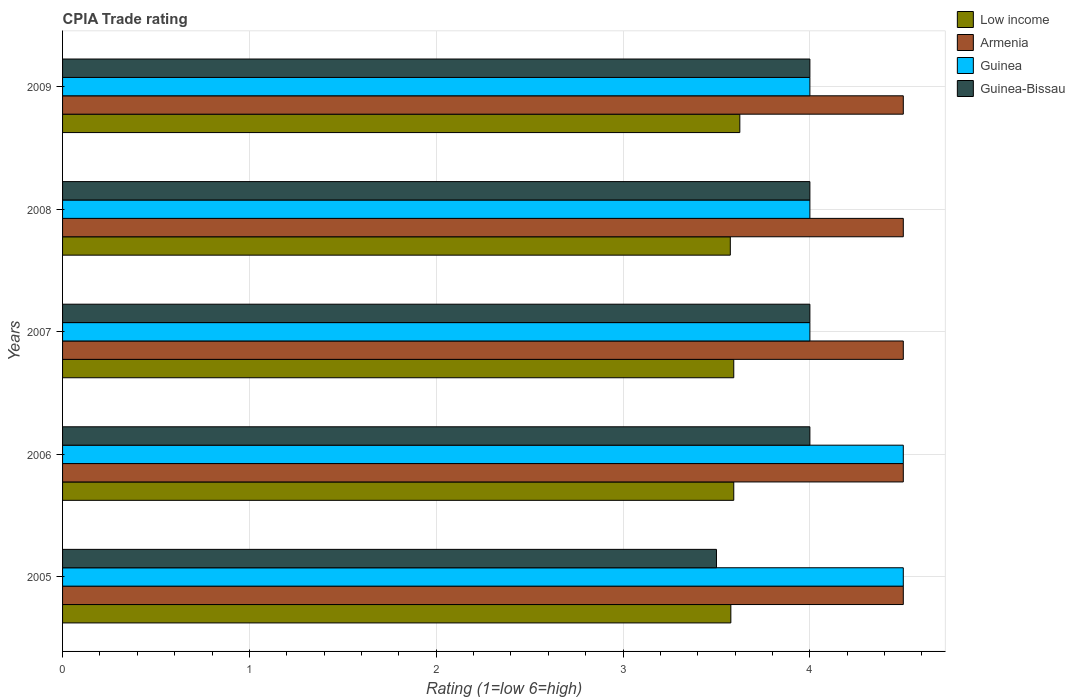How many groups of bars are there?
Your answer should be compact. 5. Are the number of bars on each tick of the Y-axis equal?
Offer a very short reply. Yes. How many bars are there on the 2nd tick from the top?
Offer a terse response. 4. What is the label of the 2nd group of bars from the top?
Ensure brevity in your answer.  2008. In how many cases, is the number of bars for a given year not equal to the number of legend labels?
Provide a short and direct response. 0. What is the CPIA rating in Guinea-Bissau in 2008?
Offer a very short reply. 4. Across all years, what is the maximum CPIA rating in Armenia?
Ensure brevity in your answer.  4.5. In which year was the CPIA rating in Low income maximum?
Your answer should be compact. 2009. What is the total CPIA rating in Low income in the graph?
Your answer should be compact. 17.96. In the year 2006, what is the difference between the CPIA rating in Guinea and CPIA rating in Guinea-Bissau?
Ensure brevity in your answer.  0.5. In how many years, is the CPIA rating in Guinea greater than 1.4 ?
Provide a succinct answer. 5. Is the difference between the CPIA rating in Guinea in 2007 and 2008 greater than the difference between the CPIA rating in Guinea-Bissau in 2007 and 2008?
Your answer should be very brief. No. What is the difference between the highest and the second highest CPIA rating in Guinea?
Offer a very short reply. 0. What is the difference between the highest and the lowest CPIA rating in Armenia?
Provide a short and direct response. 0. What does the 2nd bar from the top in 2005 represents?
Your response must be concise. Guinea. What does the 2nd bar from the bottom in 2006 represents?
Provide a short and direct response. Armenia. How many years are there in the graph?
Offer a very short reply. 5. What is the difference between two consecutive major ticks on the X-axis?
Your answer should be compact. 1. Does the graph contain grids?
Make the answer very short. Yes. Where does the legend appear in the graph?
Give a very brief answer. Top right. How many legend labels are there?
Keep it short and to the point. 4. What is the title of the graph?
Your answer should be compact. CPIA Trade rating. What is the label or title of the Y-axis?
Ensure brevity in your answer.  Years. What is the Rating (1=low 6=high) of Low income in 2005?
Provide a succinct answer. 3.58. What is the Rating (1=low 6=high) of Armenia in 2005?
Make the answer very short. 4.5. What is the Rating (1=low 6=high) in Guinea-Bissau in 2005?
Give a very brief answer. 3.5. What is the Rating (1=low 6=high) of Low income in 2006?
Keep it short and to the point. 3.59. What is the Rating (1=low 6=high) in Armenia in 2006?
Give a very brief answer. 4.5. What is the Rating (1=low 6=high) of Guinea-Bissau in 2006?
Your answer should be very brief. 4. What is the Rating (1=low 6=high) of Low income in 2007?
Your answer should be very brief. 3.59. What is the Rating (1=low 6=high) of Guinea-Bissau in 2007?
Offer a terse response. 4. What is the Rating (1=low 6=high) in Low income in 2008?
Offer a very short reply. 3.57. What is the Rating (1=low 6=high) in Armenia in 2008?
Make the answer very short. 4.5. What is the Rating (1=low 6=high) of Low income in 2009?
Give a very brief answer. 3.62. What is the Rating (1=low 6=high) of Armenia in 2009?
Offer a very short reply. 4.5. What is the Rating (1=low 6=high) in Guinea in 2009?
Make the answer very short. 4. Across all years, what is the maximum Rating (1=low 6=high) of Low income?
Your response must be concise. 3.62. Across all years, what is the maximum Rating (1=low 6=high) of Armenia?
Ensure brevity in your answer.  4.5. Across all years, what is the minimum Rating (1=low 6=high) in Low income?
Provide a short and direct response. 3.57. Across all years, what is the minimum Rating (1=low 6=high) in Guinea?
Ensure brevity in your answer.  4. What is the total Rating (1=low 6=high) in Low income in the graph?
Give a very brief answer. 17.96. What is the total Rating (1=low 6=high) in Armenia in the graph?
Provide a short and direct response. 22.5. What is the total Rating (1=low 6=high) of Guinea in the graph?
Your response must be concise. 21. What is the total Rating (1=low 6=high) of Guinea-Bissau in the graph?
Provide a succinct answer. 19.5. What is the difference between the Rating (1=low 6=high) of Low income in 2005 and that in 2006?
Your response must be concise. -0.02. What is the difference between the Rating (1=low 6=high) in Low income in 2005 and that in 2007?
Make the answer very short. -0.02. What is the difference between the Rating (1=low 6=high) of Guinea-Bissau in 2005 and that in 2007?
Your answer should be very brief. -0.5. What is the difference between the Rating (1=low 6=high) of Low income in 2005 and that in 2008?
Your response must be concise. 0. What is the difference between the Rating (1=low 6=high) of Guinea in 2005 and that in 2008?
Give a very brief answer. 0.5. What is the difference between the Rating (1=low 6=high) of Guinea-Bissau in 2005 and that in 2008?
Offer a terse response. -0.5. What is the difference between the Rating (1=low 6=high) of Low income in 2005 and that in 2009?
Provide a succinct answer. -0.05. What is the difference between the Rating (1=low 6=high) in Low income in 2006 and that in 2007?
Provide a succinct answer. 0. What is the difference between the Rating (1=low 6=high) of Armenia in 2006 and that in 2007?
Your answer should be very brief. 0. What is the difference between the Rating (1=low 6=high) of Low income in 2006 and that in 2008?
Provide a short and direct response. 0.02. What is the difference between the Rating (1=low 6=high) in Armenia in 2006 and that in 2008?
Ensure brevity in your answer.  0. What is the difference between the Rating (1=low 6=high) of Guinea in 2006 and that in 2008?
Provide a succinct answer. 0.5. What is the difference between the Rating (1=low 6=high) in Low income in 2006 and that in 2009?
Give a very brief answer. -0.03. What is the difference between the Rating (1=low 6=high) of Armenia in 2006 and that in 2009?
Your answer should be compact. 0. What is the difference between the Rating (1=low 6=high) of Guinea in 2006 and that in 2009?
Give a very brief answer. 0.5. What is the difference between the Rating (1=low 6=high) of Guinea-Bissau in 2006 and that in 2009?
Give a very brief answer. 0. What is the difference between the Rating (1=low 6=high) in Low income in 2007 and that in 2008?
Ensure brevity in your answer.  0.02. What is the difference between the Rating (1=low 6=high) of Armenia in 2007 and that in 2008?
Your answer should be very brief. 0. What is the difference between the Rating (1=low 6=high) of Guinea-Bissau in 2007 and that in 2008?
Give a very brief answer. 0. What is the difference between the Rating (1=low 6=high) in Low income in 2007 and that in 2009?
Your response must be concise. -0.03. What is the difference between the Rating (1=low 6=high) of Armenia in 2007 and that in 2009?
Offer a terse response. 0. What is the difference between the Rating (1=low 6=high) in Low income in 2008 and that in 2009?
Keep it short and to the point. -0.05. What is the difference between the Rating (1=low 6=high) of Guinea in 2008 and that in 2009?
Your answer should be compact. 0. What is the difference between the Rating (1=low 6=high) of Guinea-Bissau in 2008 and that in 2009?
Your response must be concise. 0. What is the difference between the Rating (1=low 6=high) in Low income in 2005 and the Rating (1=low 6=high) in Armenia in 2006?
Give a very brief answer. -0.92. What is the difference between the Rating (1=low 6=high) of Low income in 2005 and the Rating (1=low 6=high) of Guinea in 2006?
Provide a succinct answer. -0.92. What is the difference between the Rating (1=low 6=high) in Low income in 2005 and the Rating (1=low 6=high) in Guinea-Bissau in 2006?
Your response must be concise. -0.42. What is the difference between the Rating (1=low 6=high) in Armenia in 2005 and the Rating (1=low 6=high) in Guinea-Bissau in 2006?
Your answer should be compact. 0.5. What is the difference between the Rating (1=low 6=high) in Low income in 2005 and the Rating (1=low 6=high) in Armenia in 2007?
Your answer should be compact. -0.92. What is the difference between the Rating (1=low 6=high) of Low income in 2005 and the Rating (1=low 6=high) of Guinea in 2007?
Offer a very short reply. -0.42. What is the difference between the Rating (1=low 6=high) of Low income in 2005 and the Rating (1=low 6=high) of Guinea-Bissau in 2007?
Your answer should be very brief. -0.42. What is the difference between the Rating (1=low 6=high) of Armenia in 2005 and the Rating (1=low 6=high) of Guinea in 2007?
Make the answer very short. 0.5. What is the difference between the Rating (1=low 6=high) in Guinea in 2005 and the Rating (1=low 6=high) in Guinea-Bissau in 2007?
Offer a very short reply. 0.5. What is the difference between the Rating (1=low 6=high) in Low income in 2005 and the Rating (1=low 6=high) in Armenia in 2008?
Provide a short and direct response. -0.92. What is the difference between the Rating (1=low 6=high) of Low income in 2005 and the Rating (1=low 6=high) of Guinea in 2008?
Your response must be concise. -0.42. What is the difference between the Rating (1=low 6=high) of Low income in 2005 and the Rating (1=low 6=high) of Guinea-Bissau in 2008?
Your answer should be very brief. -0.42. What is the difference between the Rating (1=low 6=high) of Armenia in 2005 and the Rating (1=low 6=high) of Guinea in 2008?
Keep it short and to the point. 0.5. What is the difference between the Rating (1=low 6=high) of Armenia in 2005 and the Rating (1=low 6=high) of Guinea-Bissau in 2008?
Your answer should be very brief. 0.5. What is the difference between the Rating (1=low 6=high) in Low income in 2005 and the Rating (1=low 6=high) in Armenia in 2009?
Your response must be concise. -0.92. What is the difference between the Rating (1=low 6=high) of Low income in 2005 and the Rating (1=low 6=high) of Guinea in 2009?
Your response must be concise. -0.42. What is the difference between the Rating (1=low 6=high) of Low income in 2005 and the Rating (1=low 6=high) of Guinea-Bissau in 2009?
Keep it short and to the point. -0.42. What is the difference between the Rating (1=low 6=high) in Armenia in 2005 and the Rating (1=low 6=high) in Guinea-Bissau in 2009?
Your response must be concise. 0.5. What is the difference between the Rating (1=low 6=high) of Low income in 2006 and the Rating (1=low 6=high) of Armenia in 2007?
Your answer should be compact. -0.91. What is the difference between the Rating (1=low 6=high) of Low income in 2006 and the Rating (1=low 6=high) of Guinea in 2007?
Give a very brief answer. -0.41. What is the difference between the Rating (1=low 6=high) in Low income in 2006 and the Rating (1=low 6=high) in Guinea-Bissau in 2007?
Provide a short and direct response. -0.41. What is the difference between the Rating (1=low 6=high) of Armenia in 2006 and the Rating (1=low 6=high) of Guinea in 2007?
Keep it short and to the point. 0.5. What is the difference between the Rating (1=low 6=high) in Low income in 2006 and the Rating (1=low 6=high) in Armenia in 2008?
Offer a very short reply. -0.91. What is the difference between the Rating (1=low 6=high) in Low income in 2006 and the Rating (1=low 6=high) in Guinea in 2008?
Your response must be concise. -0.41. What is the difference between the Rating (1=low 6=high) in Low income in 2006 and the Rating (1=low 6=high) in Guinea-Bissau in 2008?
Offer a very short reply. -0.41. What is the difference between the Rating (1=low 6=high) in Armenia in 2006 and the Rating (1=low 6=high) in Guinea-Bissau in 2008?
Give a very brief answer. 0.5. What is the difference between the Rating (1=low 6=high) of Guinea in 2006 and the Rating (1=low 6=high) of Guinea-Bissau in 2008?
Ensure brevity in your answer.  0.5. What is the difference between the Rating (1=low 6=high) of Low income in 2006 and the Rating (1=low 6=high) of Armenia in 2009?
Provide a short and direct response. -0.91. What is the difference between the Rating (1=low 6=high) in Low income in 2006 and the Rating (1=low 6=high) in Guinea in 2009?
Your response must be concise. -0.41. What is the difference between the Rating (1=low 6=high) of Low income in 2006 and the Rating (1=low 6=high) of Guinea-Bissau in 2009?
Give a very brief answer. -0.41. What is the difference between the Rating (1=low 6=high) in Armenia in 2006 and the Rating (1=low 6=high) in Guinea in 2009?
Keep it short and to the point. 0.5. What is the difference between the Rating (1=low 6=high) in Armenia in 2006 and the Rating (1=low 6=high) in Guinea-Bissau in 2009?
Your response must be concise. 0.5. What is the difference between the Rating (1=low 6=high) of Guinea in 2006 and the Rating (1=low 6=high) of Guinea-Bissau in 2009?
Ensure brevity in your answer.  0.5. What is the difference between the Rating (1=low 6=high) of Low income in 2007 and the Rating (1=low 6=high) of Armenia in 2008?
Offer a terse response. -0.91. What is the difference between the Rating (1=low 6=high) of Low income in 2007 and the Rating (1=low 6=high) of Guinea in 2008?
Your answer should be very brief. -0.41. What is the difference between the Rating (1=low 6=high) of Low income in 2007 and the Rating (1=low 6=high) of Guinea-Bissau in 2008?
Your answer should be very brief. -0.41. What is the difference between the Rating (1=low 6=high) in Armenia in 2007 and the Rating (1=low 6=high) in Guinea in 2008?
Your answer should be compact. 0.5. What is the difference between the Rating (1=low 6=high) in Armenia in 2007 and the Rating (1=low 6=high) in Guinea-Bissau in 2008?
Provide a short and direct response. 0.5. What is the difference between the Rating (1=low 6=high) in Guinea in 2007 and the Rating (1=low 6=high) in Guinea-Bissau in 2008?
Provide a short and direct response. 0. What is the difference between the Rating (1=low 6=high) of Low income in 2007 and the Rating (1=low 6=high) of Armenia in 2009?
Provide a short and direct response. -0.91. What is the difference between the Rating (1=low 6=high) in Low income in 2007 and the Rating (1=low 6=high) in Guinea in 2009?
Your answer should be very brief. -0.41. What is the difference between the Rating (1=low 6=high) in Low income in 2007 and the Rating (1=low 6=high) in Guinea-Bissau in 2009?
Provide a short and direct response. -0.41. What is the difference between the Rating (1=low 6=high) in Guinea in 2007 and the Rating (1=low 6=high) in Guinea-Bissau in 2009?
Your answer should be compact. 0. What is the difference between the Rating (1=low 6=high) in Low income in 2008 and the Rating (1=low 6=high) in Armenia in 2009?
Your answer should be compact. -0.93. What is the difference between the Rating (1=low 6=high) of Low income in 2008 and the Rating (1=low 6=high) of Guinea in 2009?
Give a very brief answer. -0.43. What is the difference between the Rating (1=low 6=high) in Low income in 2008 and the Rating (1=low 6=high) in Guinea-Bissau in 2009?
Provide a succinct answer. -0.43. What is the difference between the Rating (1=low 6=high) in Guinea in 2008 and the Rating (1=low 6=high) in Guinea-Bissau in 2009?
Ensure brevity in your answer.  0. What is the average Rating (1=low 6=high) in Low income per year?
Offer a terse response. 3.59. What is the average Rating (1=low 6=high) in Guinea-Bissau per year?
Make the answer very short. 3.9. In the year 2005, what is the difference between the Rating (1=low 6=high) of Low income and Rating (1=low 6=high) of Armenia?
Offer a terse response. -0.92. In the year 2005, what is the difference between the Rating (1=low 6=high) in Low income and Rating (1=low 6=high) in Guinea?
Make the answer very short. -0.92. In the year 2005, what is the difference between the Rating (1=low 6=high) in Low income and Rating (1=low 6=high) in Guinea-Bissau?
Your response must be concise. 0.08. In the year 2005, what is the difference between the Rating (1=low 6=high) in Armenia and Rating (1=low 6=high) in Guinea?
Your answer should be compact. 0. In the year 2006, what is the difference between the Rating (1=low 6=high) of Low income and Rating (1=low 6=high) of Armenia?
Your answer should be very brief. -0.91. In the year 2006, what is the difference between the Rating (1=low 6=high) in Low income and Rating (1=low 6=high) in Guinea?
Offer a terse response. -0.91. In the year 2006, what is the difference between the Rating (1=low 6=high) in Low income and Rating (1=low 6=high) in Guinea-Bissau?
Your response must be concise. -0.41. In the year 2006, what is the difference between the Rating (1=low 6=high) in Armenia and Rating (1=low 6=high) in Guinea?
Keep it short and to the point. 0. In the year 2006, what is the difference between the Rating (1=low 6=high) of Armenia and Rating (1=low 6=high) of Guinea-Bissau?
Ensure brevity in your answer.  0.5. In the year 2007, what is the difference between the Rating (1=low 6=high) of Low income and Rating (1=low 6=high) of Armenia?
Provide a short and direct response. -0.91. In the year 2007, what is the difference between the Rating (1=low 6=high) in Low income and Rating (1=low 6=high) in Guinea?
Provide a succinct answer. -0.41. In the year 2007, what is the difference between the Rating (1=low 6=high) in Low income and Rating (1=low 6=high) in Guinea-Bissau?
Keep it short and to the point. -0.41. In the year 2007, what is the difference between the Rating (1=low 6=high) of Armenia and Rating (1=low 6=high) of Guinea-Bissau?
Your answer should be compact. 0.5. In the year 2007, what is the difference between the Rating (1=low 6=high) in Guinea and Rating (1=low 6=high) in Guinea-Bissau?
Your answer should be very brief. 0. In the year 2008, what is the difference between the Rating (1=low 6=high) of Low income and Rating (1=low 6=high) of Armenia?
Provide a succinct answer. -0.93. In the year 2008, what is the difference between the Rating (1=low 6=high) in Low income and Rating (1=low 6=high) in Guinea?
Provide a succinct answer. -0.43. In the year 2008, what is the difference between the Rating (1=low 6=high) of Low income and Rating (1=low 6=high) of Guinea-Bissau?
Provide a succinct answer. -0.43. In the year 2008, what is the difference between the Rating (1=low 6=high) of Armenia and Rating (1=low 6=high) of Guinea?
Your response must be concise. 0.5. In the year 2009, what is the difference between the Rating (1=low 6=high) of Low income and Rating (1=low 6=high) of Armenia?
Your answer should be very brief. -0.88. In the year 2009, what is the difference between the Rating (1=low 6=high) in Low income and Rating (1=low 6=high) in Guinea?
Your answer should be compact. -0.38. In the year 2009, what is the difference between the Rating (1=low 6=high) of Low income and Rating (1=low 6=high) of Guinea-Bissau?
Give a very brief answer. -0.38. In the year 2009, what is the difference between the Rating (1=low 6=high) of Armenia and Rating (1=low 6=high) of Guinea?
Your answer should be very brief. 0.5. What is the ratio of the Rating (1=low 6=high) in Low income in 2005 to that in 2006?
Offer a terse response. 1. What is the ratio of the Rating (1=low 6=high) in Low income in 2005 to that in 2007?
Ensure brevity in your answer.  1. What is the ratio of the Rating (1=low 6=high) of Armenia in 2005 to that in 2007?
Your answer should be very brief. 1. What is the ratio of the Rating (1=low 6=high) of Guinea in 2005 to that in 2007?
Your answer should be compact. 1.12. What is the ratio of the Rating (1=low 6=high) in Low income in 2005 to that in 2008?
Give a very brief answer. 1. What is the ratio of the Rating (1=low 6=high) in Low income in 2005 to that in 2009?
Ensure brevity in your answer.  0.99. What is the ratio of the Rating (1=low 6=high) of Armenia in 2005 to that in 2009?
Give a very brief answer. 1. What is the ratio of the Rating (1=low 6=high) of Guinea in 2005 to that in 2009?
Give a very brief answer. 1.12. What is the ratio of the Rating (1=low 6=high) in Guinea-Bissau in 2005 to that in 2009?
Provide a succinct answer. 0.88. What is the ratio of the Rating (1=low 6=high) in Low income in 2006 to that in 2007?
Give a very brief answer. 1. What is the ratio of the Rating (1=low 6=high) of Armenia in 2006 to that in 2007?
Keep it short and to the point. 1. What is the ratio of the Rating (1=low 6=high) of Guinea-Bissau in 2006 to that in 2007?
Ensure brevity in your answer.  1. What is the ratio of the Rating (1=low 6=high) of Guinea in 2006 to that in 2008?
Your answer should be compact. 1.12. What is the ratio of the Rating (1=low 6=high) of Low income in 2006 to that in 2009?
Your answer should be compact. 0.99. What is the ratio of the Rating (1=low 6=high) in Guinea-Bissau in 2006 to that in 2009?
Your answer should be compact. 1. What is the ratio of the Rating (1=low 6=high) in Low income in 2007 to that in 2008?
Make the answer very short. 1.01. What is the ratio of the Rating (1=low 6=high) in Armenia in 2007 to that in 2008?
Your answer should be compact. 1. What is the ratio of the Rating (1=low 6=high) in Guinea in 2007 to that in 2009?
Offer a very short reply. 1. What is the ratio of the Rating (1=low 6=high) of Guinea-Bissau in 2007 to that in 2009?
Ensure brevity in your answer.  1. What is the ratio of the Rating (1=low 6=high) in Armenia in 2008 to that in 2009?
Ensure brevity in your answer.  1. What is the difference between the highest and the second highest Rating (1=low 6=high) of Low income?
Your answer should be very brief. 0.03. What is the difference between the highest and the second highest Rating (1=low 6=high) in Guinea?
Your response must be concise. 0. What is the difference between the highest and the second highest Rating (1=low 6=high) of Guinea-Bissau?
Your answer should be very brief. 0. What is the difference between the highest and the lowest Rating (1=low 6=high) of Low income?
Provide a short and direct response. 0.05. What is the difference between the highest and the lowest Rating (1=low 6=high) in Armenia?
Make the answer very short. 0. What is the difference between the highest and the lowest Rating (1=low 6=high) in Guinea-Bissau?
Provide a succinct answer. 0.5. 